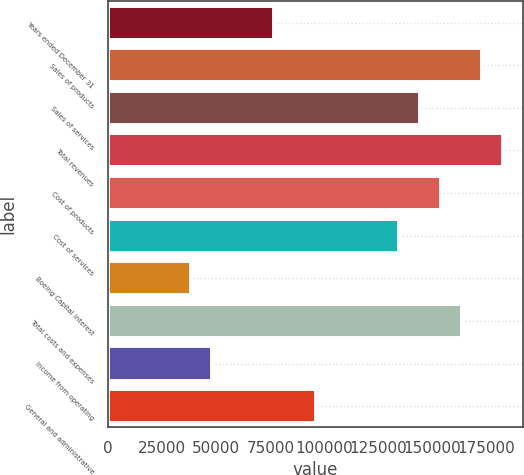Convert chart. <chart><loc_0><loc_0><loc_500><loc_500><bar_chart><fcel>Years ended December 31<fcel>Sales of products<fcel>Sales of services<fcel>Total revenues<fcel>Cost of products<fcel>Cost of services<fcel>Boeing Capital interest<fcel>Total costs and expenses<fcel>Income from operating<fcel>General and administrative<nl><fcel>76891.4<fcel>173004<fcel>144170<fcel>182616<fcel>153782<fcel>134559<fcel>38446.2<fcel>163393<fcel>48057.5<fcel>96114<nl></chart> 